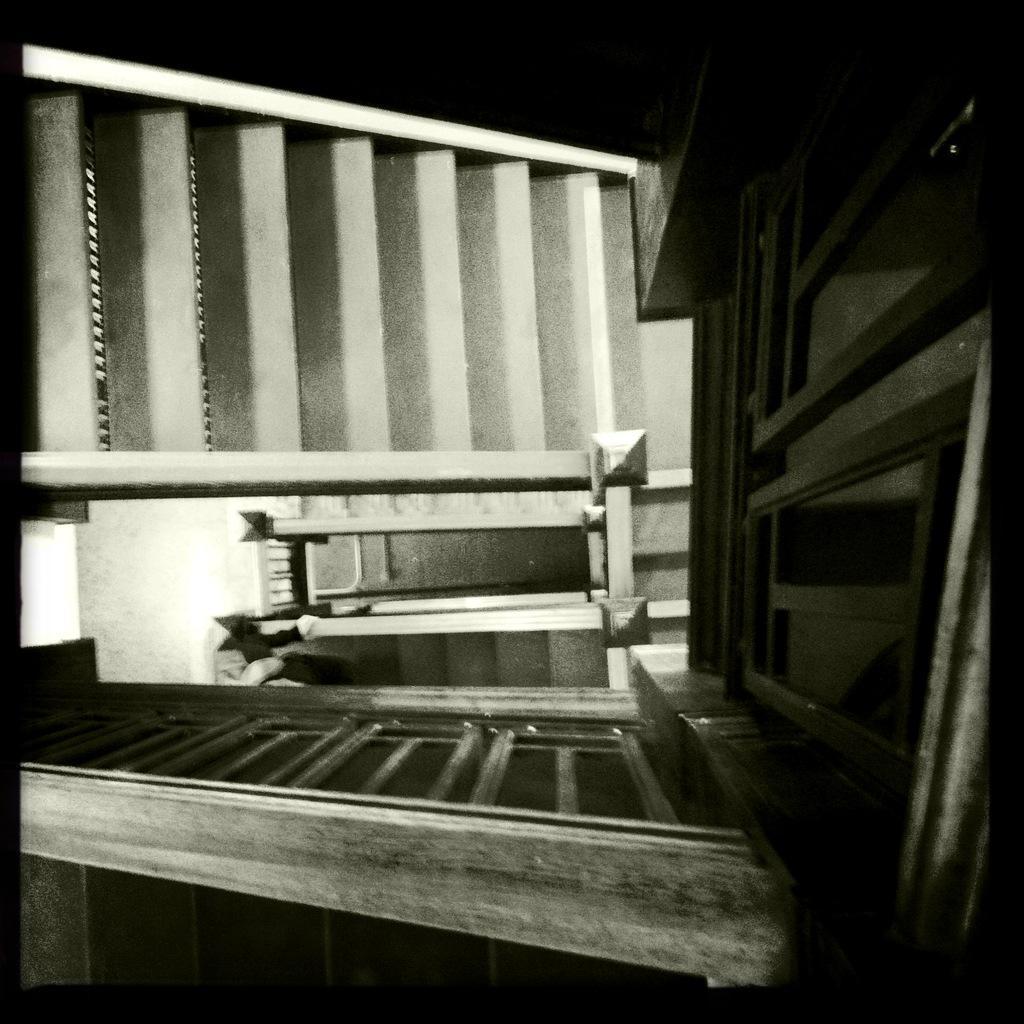In one or two sentences, can you explain what this image depicts? This image looks like an edited photo, in which I can see buildings, walls and a bridge. 